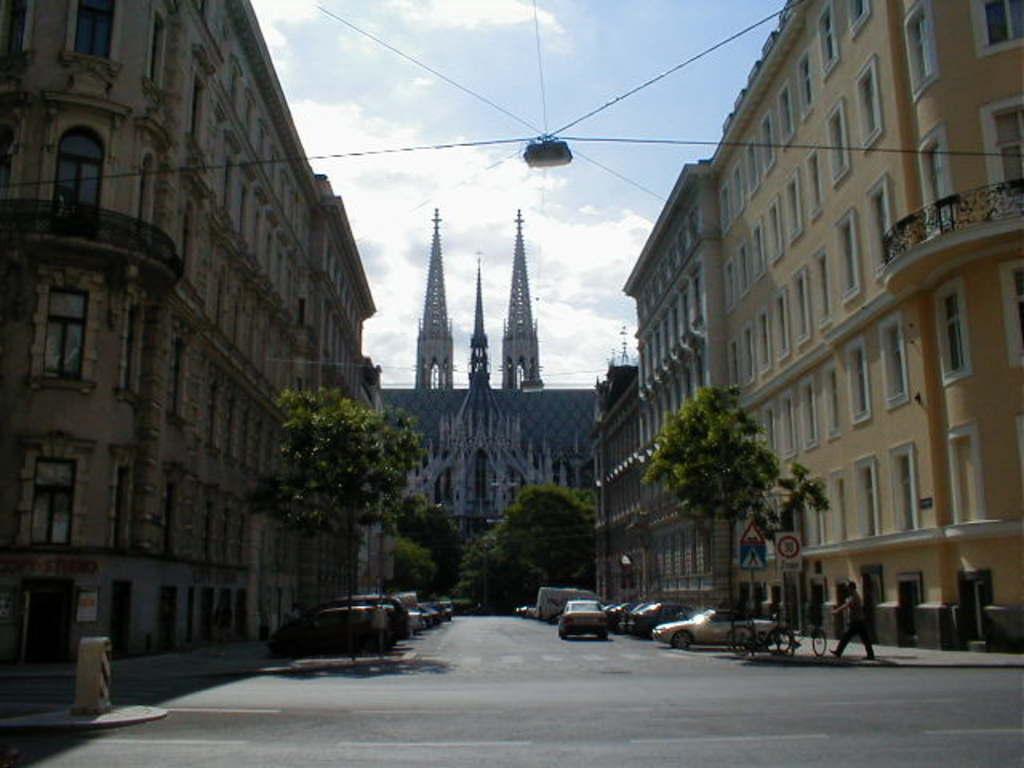Could you give a brief overview of what you see in this image? In the picture we can see a road on the either sides of the road we can see some cars are parked near the path and trees near it and we can also see buildings with number of windows and in the background we can see some trees and a church building and behind it we can see a sky with clouds and on the path we can see a man walking and we can also see some bicycles. 